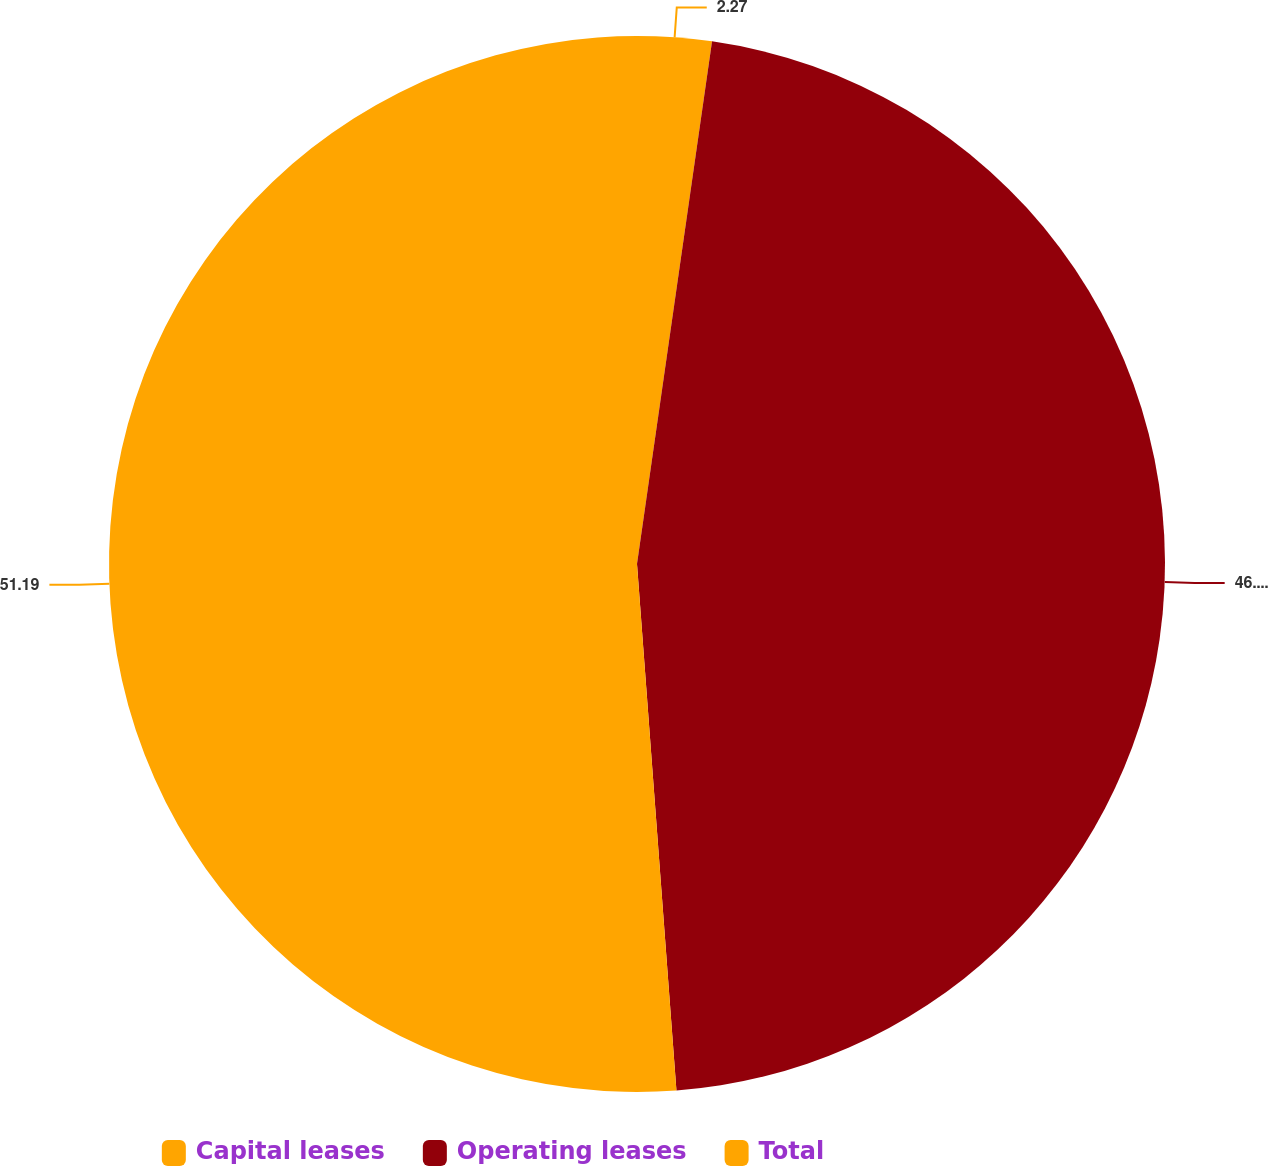<chart> <loc_0><loc_0><loc_500><loc_500><pie_chart><fcel>Capital leases<fcel>Operating leases<fcel>Total<nl><fcel>2.27%<fcel>46.54%<fcel>51.19%<nl></chart> 